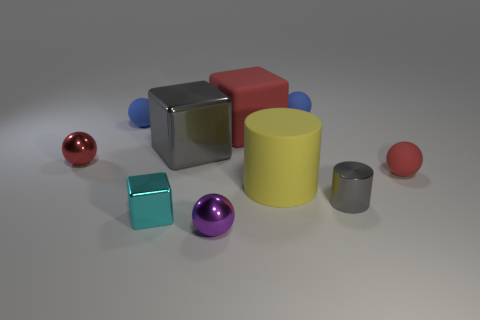Can you describe the shapes and materials present in the image? Certainly! The image showcases a variety of geometric shapes made of different materials. There's a shiny metal cube, a glossy red block, and a matte yellow cylinder, reflecting the diversity of shapes and finishes. Two small metal spheres, one large and one smaller red sphere, and two small purple spheres add to the collection. The objects are arranged casually on a flat surface, which gives the composition a sense of balance between form and color. 